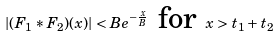Convert formula to latex. <formula><loc_0><loc_0><loc_500><loc_500>| ( F _ { 1 } \ast F _ { 2 } ) ( x ) | < B e ^ { - \frac { x } { B } } \text { for } x > t _ { 1 } + t _ { 2 }</formula> 